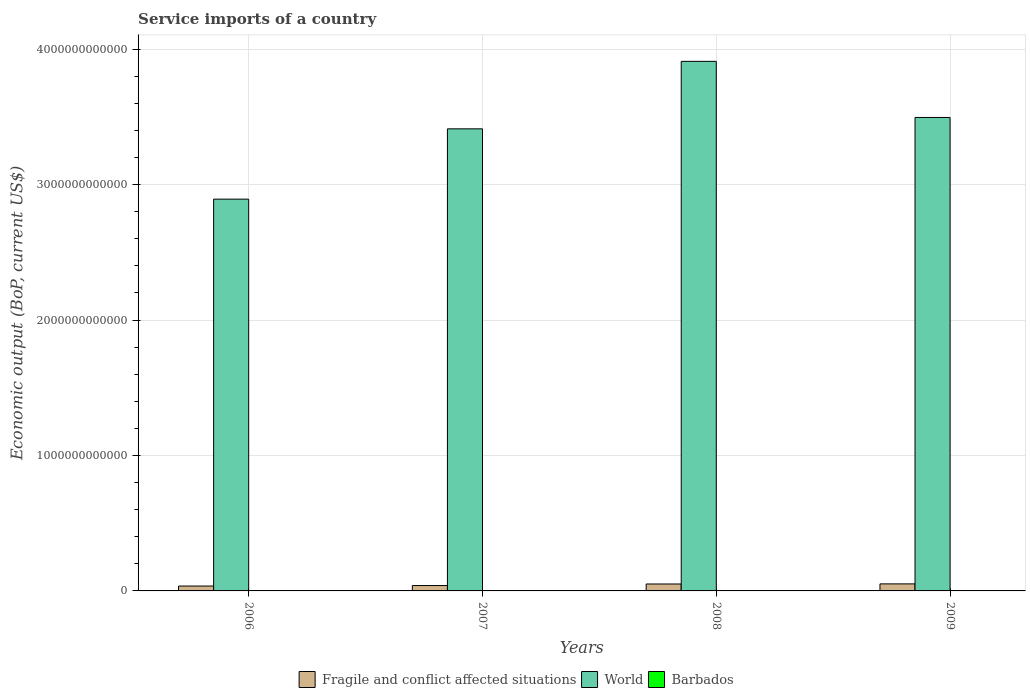How many groups of bars are there?
Offer a terse response. 4. Are the number of bars per tick equal to the number of legend labels?
Make the answer very short. Yes. How many bars are there on the 2nd tick from the left?
Offer a very short reply. 3. What is the label of the 3rd group of bars from the left?
Offer a very short reply. 2008. In how many cases, is the number of bars for a given year not equal to the number of legend labels?
Keep it short and to the point. 0. What is the service imports in Barbados in 2006?
Offer a terse response. 6.92e+08. Across all years, what is the maximum service imports in Barbados?
Offer a terse response. 7.58e+08. Across all years, what is the minimum service imports in Fragile and conflict affected situations?
Provide a succinct answer. 3.61e+1. What is the total service imports in World in the graph?
Give a very brief answer. 1.37e+13. What is the difference between the service imports in World in 2007 and that in 2009?
Provide a succinct answer. -8.39e+1. What is the difference between the service imports in World in 2008 and the service imports in Barbados in 2009?
Make the answer very short. 3.91e+12. What is the average service imports in World per year?
Your answer should be very brief. 3.43e+12. In the year 2009, what is the difference between the service imports in Barbados and service imports in World?
Give a very brief answer. -3.49e+12. What is the ratio of the service imports in World in 2006 to that in 2007?
Provide a succinct answer. 0.85. Is the difference between the service imports in Barbados in 2007 and 2008 greater than the difference between the service imports in World in 2007 and 2008?
Provide a succinct answer. Yes. What is the difference between the highest and the second highest service imports in Fragile and conflict affected situations?
Offer a very short reply. 7.92e+08. What is the difference between the highest and the lowest service imports in Fragile and conflict affected situations?
Your answer should be compact. 1.58e+1. Is the sum of the service imports in Barbados in 2008 and 2009 greater than the maximum service imports in World across all years?
Ensure brevity in your answer.  No. What does the 3rd bar from the left in 2008 represents?
Offer a terse response. Barbados. What does the 1st bar from the right in 2009 represents?
Offer a terse response. Barbados. Is it the case that in every year, the sum of the service imports in Barbados and service imports in Fragile and conflict affected situations is greater than the service imports in World?
Offer a very short reply. No. How many bars are there?
Give a very brief answer. 12. What is the difference between two consecutive major ticks on the Y-axis?
Keep it short and to the point. 1.00e+12. Does the graph contain grids?
Your response must be concise. Yes. Where does the legend appear in the graph?
Offer a terse response. Bottom center. What is the title of the graph?
Your response must be concise. Service imports of a country. Does "Bolivia" appear as one of the legend labels in the graph?
Provide a short and direct response. No. What is the label or title of the Y-axis?
Ensure brevity in your answer.  Economic output (BoP, current US$). What is the Economic output (BoP, current US$) in Fragile and conflict affected situations in 2006?
Offer a very short reply. 3.61e+1. What is the Economic output (BoP, current US$) of World in 2006?
Your answer should be very brief. 2.89e+12. What is the Economic output (BoP, current US$) in Barbados in 2006?
Keep it short and to the point. 6.92e+08. What is the Economic output (BoP, current US$) of Fragile and conflict affected situations in 2007?
Provide a succinct answer. 3.98e+1. What is the Economic output (BoP, current US$) of World in 2007?
Your answer should be very brief. 3.41e+12. What is the Economic output (BoP, current US$) in Barbados in 2007?
Make the answer very short. 6.69e+08. What is the Economic output (BoP, current US$) of Fragile and conflict affected situations in 2008?
Keep it short and to the point. 5.11e+1. What is the Economic output (BoP, current US$) in World in 2008?
Give a very brief answer. 3.91e+12. What is the Economic output (BoP, current US$) in Barbados in 2008?
Provide a succinct answer. 7.58e+08. What is the Economic output (BoP, current US$) of Fragile and conflict affected situations in 2009?
Give a very brief answer. 5.19e+1. What is the Economic output (BoP, current US$) in World in 2009?
Offer a very short reply. 3.50e+12. What is the Economic output (BoP, current US$) in Barbados in 2009?
Your answer should be very brief. 7.11e+08. Across all years, what is the maximum Economic output (BoP, current US$) in Fragile and conflict affected situations?
Make the answer very short. 5.19e+1. Across all years, what is the maximum Economic output (BoP, current US$) of World?
Your answer should be very brief. 3.91e+12. Across all years, what is the maximum Economic output (BoP, current US$) of Barbados?
Your answer should be compact. 7.58e+08. Across all years, what is the minimum Economic output (BoP, current US$) of Fragile and conflict affected situations?
Keep it short and to the point. 3.61e+1. Across all years, what is the minimum Economic output (BoP, current US$) of World?
Your answer should be compact. 2.89e+12. Across all years, what is the minimum Economic output (BoP, current US$) in Barbados?
Your answer should be very brief. 6.69e+08. What is the total Economic output (BoP, current US$) of Fragile and conflict affected situations in the graph?
Give a very brief answer. 1.79e+11. What is the total Economic output (BoP, current US$) in World in the graph?
Your answer should be compact. 1.37e+13. What is the total Economic output (BoP, current US$) of Barbados in the graph?
Make the answer very short. 2.83e+09. What is the difference between the Economic output (BoP, current US$) of Fragile and conflict affected situations in 2006 and that in 2007?
Your response must be concise. -3.68e+09. What is the difference between the Economic output (BoP, current US$) of World in 2006 and that in 2007?
Keep it short and to the point. -5.19e+11. What is the difference between the Economic output (BoP, current US$) of Barbados in 2006 and that in 2007?
Make the answer very short. 2.33e+07. What is the difference between the Economic output (BoP, current US$) of Fragile and conflict affected situations in 2006 and that in 2008?
Your answer should be compact. -1.50e+1. What is the difference between the Economic output (BoP, current US$) of World in 2006 and that in 2008?
Your answer should be very brief. -1.02e+12. What is the difference between the Economic output (BoP, current US$) in Barbados in 2006 and that in 2008?
Provide a succinct answer. -6.56e+07. What is the difference between the Economic output (BoP, current US$) of Fragile and conflict affected situations in 2006 and that in 2009?
Your response must be concise. -1.58e+1. What is the difference between the Economic output (BoP, current US$) in World in 2006 and that in 2009?
Give a very brief answer. -6.03e+11. What is the difference between the Economic output (BoP, current US$) in Barbados in 2006 and that in 2009?
Offer a terse response. -1.89e+07. What is the difference between the Economic output (BoP, current US$) of Fragile and conflict affected situations in 2007 and that in 2008?
Keep it short and to the point. -1.14e+1. What is the difference between the Economic output (BoP, current US$) of World in 2007 and that in 2008?
Your answer should be compact. -4.98e+11. What is the difference between the Economic output (BoP, current US$) of Barbados in 2007 and that in 2008?
Offer a very short reply. -8.89e+07. What is the difference between the Economic output (BoP, current US$) in Fragile and conflict affected situations in 2007 and that in 2009?
Provide a succinct answer. -1.21e+1. What is the difference between the Economic output (BoP, current US$) of World in 2007 and that in 2009?
Your response must be concise. -8.39e+1. What is the difference between the Economic output (BoP, current US$) in Barbados in 2007 and that in 2009?
Keep it short and to the point. -4.22e+07. What is the difference between the Economic output (BoP, current US$) in Fragile and conflict affected situations in 2008 and that in 2009?
Provide a short and direct response. -7.92e+08. What is the difference between the Economic output (BoP, current US$) of World in 2008 and that in 2009?
Offer a terse response. 4.14e+11. What is the difference between the Economic output (BoP, current US$) in Barbados in 2008 and that in 2009?
Your response must be concise. 4.66e+07. What is the difference between the Economic output (BoP, current US$) of Fragile and conflict affected situations in 2006 and the Economic output (BoP, current US$) of World in 2007?
Keep it short and to the point. -3.38e+12. What is the difference between the Economic output (BoP, current US$) of Fragile and conflict affected situations in 2006 and the Economic output (BoP, current US$) of Barbados in 2007?
Offer a very short reply. 3.54e+1. What is the difference between the Economic output (BoP, current US$) in World in 2006 and the Economic output (BoP, current US$) in Barbados in 2007?
Ensure brevity in your answer.  2.89e+12. What is the difference between the Economic output (BoP, current US$) in Fragile and conflict affected situations in 2006 and the Economic output (BoP, current US$) in World in 2008?
Your response must be concise. -3.87e+12. What is the difference between the Economic output (BoP, current US$) in Fragile and conflict affected situations in 2006 and the Economic output (BoP, current US$) in Barbados in 2008?
Provide a short and direct response. 3.53e+1. What is the difference between the Economic output (BoP, current US$) of World in 2006 and the Economic output (BoP, current US$) of Barbados in 2008?
Provide a short and direct response. 2.89e+12. What is the difference between the Economic output (BoP, current US$) in Fragile and conflict affected situations in 2006 and the Economic output (BoP, current US$) in World in 2009?
Make the answer very short. -3.46e+12. What is the difference between the Economic output (BoP, current US$) in Fragile and conflict affected situations in 2006 and the Economic output (BoP, current US$) in Barbados in 2009?
Offer a very short reply. 3.54e+1. What is the difference between the Economic output (BoP, current US$) of World in 2006 and the Economic output (BoP, current US$) of Barbados in 2009?
Ensure brevity in your answer.  2.89e+12. What is the difference between the Economic output (BoP, current US$) of Fragile and conflict affected situations in 2007 and the Economic output (BoP, current US$) of World in 2008?
Your answer should be compact. -3.87e+12. What is the difference between the Economic output (BoP, current US$) of Fragile and conflict affected situations in 2007 and the Economic output (BoP, current US$) of Barbados in 2008?
Provide a short and direct response. 3.90e+1. What is the difference between the Economic output (BoP, current US$) in World in 2007 and the Economic output (BoP, current US$) in Barbados in 2008?
Your answer should be very brief. 3.41e+12. What is the difference between the Economic output (BoP, current US$) in Fragile and conflict affected situations in 2007 and the Economic output (BoP, current US$) in World in 2009?
Make the answer very short. -3.46e+12. What is the difference between the Economic output (BoP, current US$) of Fragile and conflict affected situations in 2007 and the Economic output (BoP, current US$) of Barbados in 2009?
Keep it short and to the point. 3.91e+1. What is the difference between the Economic output (BoP, current US$) of World in 2007 and the Economic output (BoP, current US$) of Barbados in 2009?
Provide a succinct answer. 3.41e+12. What is the difference between the Economic output (BoP, current US$) of Fragile and conflict affected situations in 2008 and the Economic output (BoP, current US$) of World in 2009?
Your answer should be compact. -3.44e+12. What is the difference between the Economic output (BoP, current US$) of Fragile and conflict affected situations in 2008 and the Economic output (BoP, current US$) of Barbados in 2009?
Your answer should be very brief. 5.04e+1. What is the difference between the Economic output (BoP, current US$) of World in 2008 and the Economic output (BoP, current US$) of Barbados in 2009?
Your answer should be compact. 3.91e+12. What is the average Economic output (BoP, current US$) in Fragile and conflict affected situations per year?
Keep it short and to the point. 4.47e+1. What is the average Economic output (BoP, current US$) in World per year?
Your response must be concise. 3.43e+12. What is the average Economic output (BoP, current US$) in Barbados per year?
Your answer should be very brief. 7.07e+08. In the year 2006, what is the difference between the Economic output (BoP, current US$) in Fragile and conflict affected situations and Economic output (BoP, current US$) in World?
Provide a short and direct response. -2.86e+12. In the year 2006, what is the difference between the Economic output (BoP, current US$) of Fragile and conflict affected situations and Economic output (BoP, current US$) of Barbados?
Provide a succinct answer. 3.54e+1. In the year 2006, what is the difference between the Economic output (BoP, current US$) in World and Economic output (BoP, current US$) in Barbados?
Offer a very short reply. 2.89e+12. In the year 2007, what is the difference between the Economic output (BoP, current US$) of Fragile and conflict affected situations and Economic output (BoP, current US$) of World?
Offer a very short reply. -3.37e+12. In the year 2007, what is the difference between the Economic output (BoP, current US$) in Fragile and conflict affected situations and Economic output (BoP, current US$) in Barbados?
Your answer should be very brief. 3.91e+1. In the year 2007, what is the difference between the Economic output (BoP, current US$) of World and Economic output (BoP, current US$) of Barbados?
Keep it short and to the point. 3.41e+12. In the year 2008, what is the difference between the Economic output (BoP, current US$) of Fragile and conflict affected situations and Economic output (BoP, current US$) of World?
Your answer should be very brief. -3.86e+12. In the year 2008, what is the difference between the Economic output (BoP, current US$) of Fragile and conflict affected situations and Economic output (BoP, current US$) of Barbados?
Your answer should be very brief. 5.04e+1. In the year 2008, what is the difference between the Economic output (BoP, current US$) of World and Economic output (BoP, current US$) of Barbados?
Offer a terse response. 3.91e+12. In the year 2009, what is the difference between the Economic output (BoP, current US$) in Fragile and conflict affected situations and Economic output (BoP, current US$) in World?
Keep it short and to the point. -3.44e+12. In the year 2009, what is the difference between the Economic output (BoP, current US$) of Fragile and conflict affected situations and Economic output (BoP, current US$) of Barbados?
Provide a succinct answer. 5.12e+1. In the year 2009, what is the difference between the Economic output (BoP, current US$) of World and Economic output (BoP, current US$) of Barbados?
Ensure brevity in your answer.  3.49e+12. What is the ratio of the Economic output (BoP, current US$) of Fragile and conflict affected situations in 2006 to that in 2007?
Provide a succinct answer. 0.91. What is the ratio of the Economic output (BoP, current US$) in World in 2006 to that in 2007?
Your response must be concise. 0.85. What is the ratio of the Economic output (BoP, current US$) of Barbados in 2006 to that in 2007?
Provide a short and direct response. 1.03. What is the ratio of the Economic output (BoP, current US$) of Fragile and conflict affected situations in 2006 to that in 2008?
Keep it short and to the point. 0.71. What is the ratio of the Economic output (BoP, current US$) of World in 2006 to that in 2008?
Provide a succinct answer. 0.74. What is the ratio of the Economic output (BoP, current US$) in Barbados in 2006 to that in 2008?
Your answer should be very brief. 0.91. What is the ratio of the Economic output (BoP, current US$) in Fragile and conflict affected situations in 2006 to that in 2009?
Your answer should be compact. 0.7. What is the ratio of the Economic output (BoP, current US$) in World in 2006 to that in 2009?
Make the answer very short. 0.83. What is the ratio of the Economic output (BoP, current US$) in Barbados in 2006 to that in 2009?
Your answer should be very brief. 0.97. What is the ratio of the Economic output (BoP, current US$) of World in 2007 to that in 2008?
Offer a terse response. 0.87. What is the ratio of the Economic output (BoP, current US$) of Barbados in 2007 to that in 2008?
Make the answer very short. 0.88. What is the ratio of the Economic output (BoP, current US$) in Fragile and conflict affected situations in 2007 to that in 2009?
Offer a terse response. 0.77. What is the ratio of the Economic output (BoP, current US$) in World in 2007 to that in 2009?
Your response must be concise. 0.98. What is the ratio of the Economic output (BoP, current US$) of Barbados in 2007 to that in 2009?
Provide a succinct answer. 0.94. What is the ratio of the Economic output (BoP, current US$) in Fragile and conflict affected situations in 2008 to that in 2009?
Ensure brevity in your answer.  0.98. What is the ratio of the Economic output (BoP, current US$) in World in 2008 to that in 2009?
Your answer should be very brief. 1.12. What is the ratio of the Economic output (BoP, current US$) in Barbados in 2008 to that in 2009?
Offer a very short reply. 1.07. What is the difference between the highest and the second highest Economic output (BoP, current US$) of Fragile and conflict affected situations?
Your response must be concise. 7.92e+08. What is the difference between the highest and the second highest Economic output (BoP, current US$) of World?
Provide a short and direct response. 4.14e+11. What is the difference between the highest and the second highest Economic output (BoP, current US$) of Barbados?
Make the answer very short. 4.66e+07. What is the difference between the highest and the lowest Economic output (BoP, current US$) in Fragile and conflict affected situations?
Offer a terse response. 1.58e+1. What is the difference between the highest and the lowest Economic output (BoP, current US$) in World?
Your answer should be very brief. 1.02e+12. What is the difference between the highest and the lowest Economic output (BoP, current US$) of Barbados?
Offer a very short reply. 8.89e+07. 